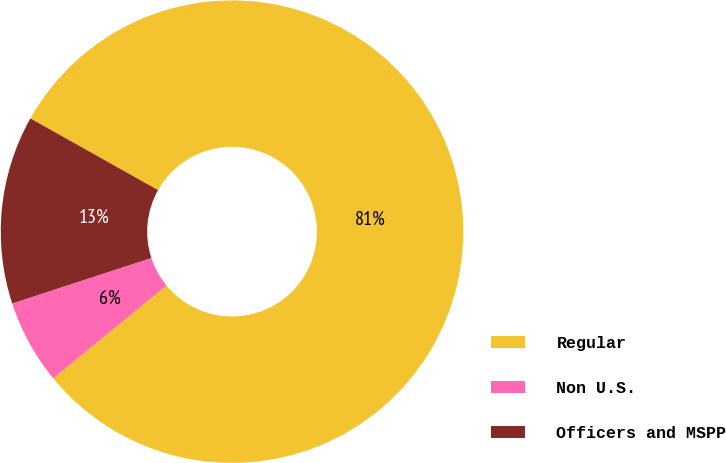Convert chart. <chart><loc_0><loc_0><loc_500><loc_500><pie_chart><fcel>Regular<fcel>Non U.S.<fcel>Officers and MSPP<nl><fcel>80.92%<fcel>5.91%<fcel>13.17%<nl></chart> 